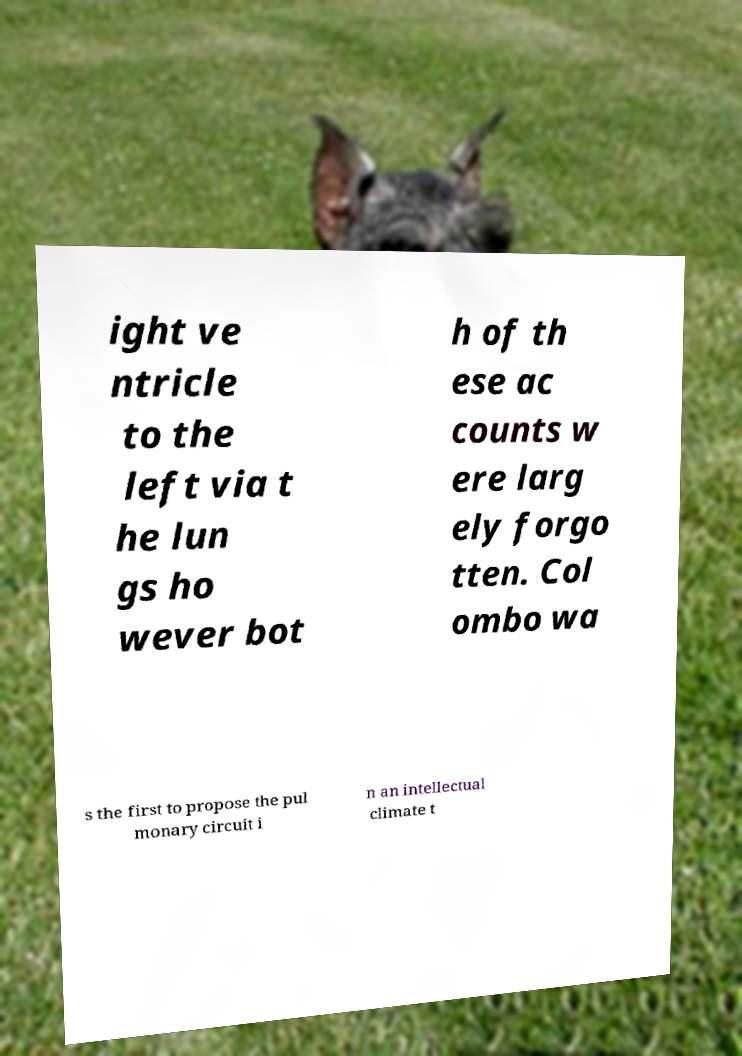What messages or text are displayed in this image? I need them in a readable, typed format. ight ve ntricle to the left via t he lun gs ho wever bot h of th ese ac counts w ere larg ely forgo tten. Col ombo wa s the first to propose the pul monary circuit i n an intellectual climate t 